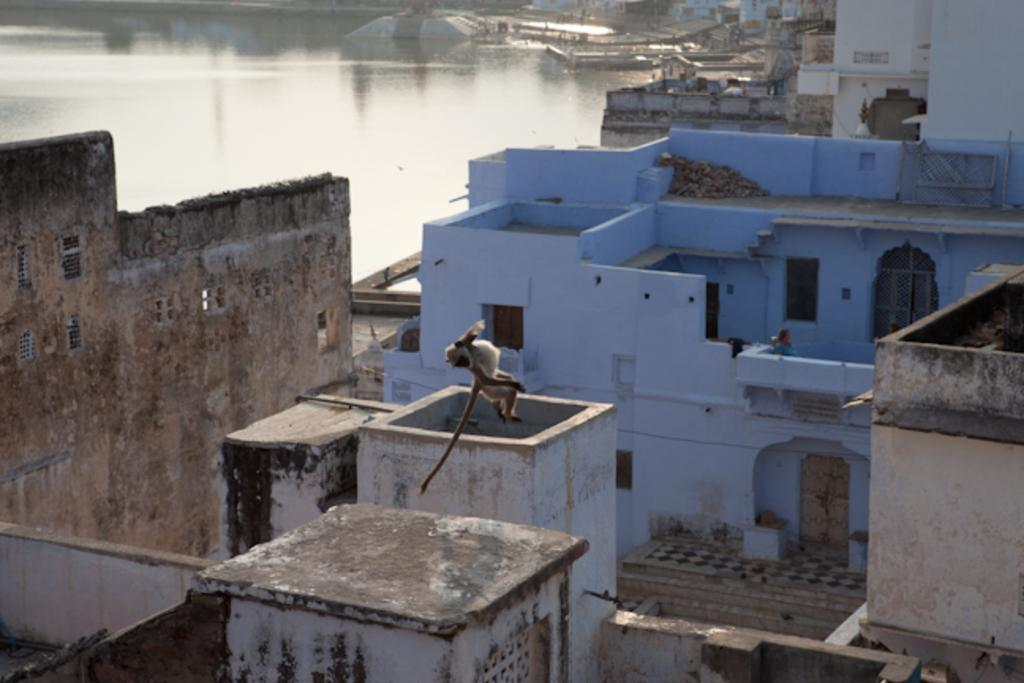What animal is present in the image? There is a monkey in the image. What is the monkey doing in the image? The monkey is jumping in the air. Can you describe the person's position in the image? There is a person sitting on top of a building. What can be seen on the right side of the image? There are buildings on the right side of the image. What is visible on the left top side of the image? There is water visible on the left top side of the image. What type of can is being used for teaching peace in the image? There is no can or teaching of peace present in the image. 